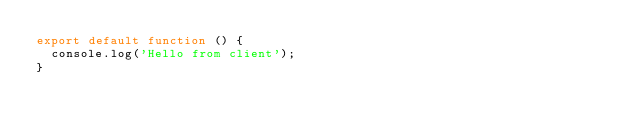<code> <loc_0><loc_0><loc_500><loc_500><_JavaScript_>export default function () {
  console.log('Hello from client');
}
</code> 